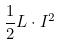Convert formula to latex. <formula><loc_0><loc_0><loc_500><loc_500>\frac { 1 } { 2 } L \cdot I ^ { 2 }</formula> 